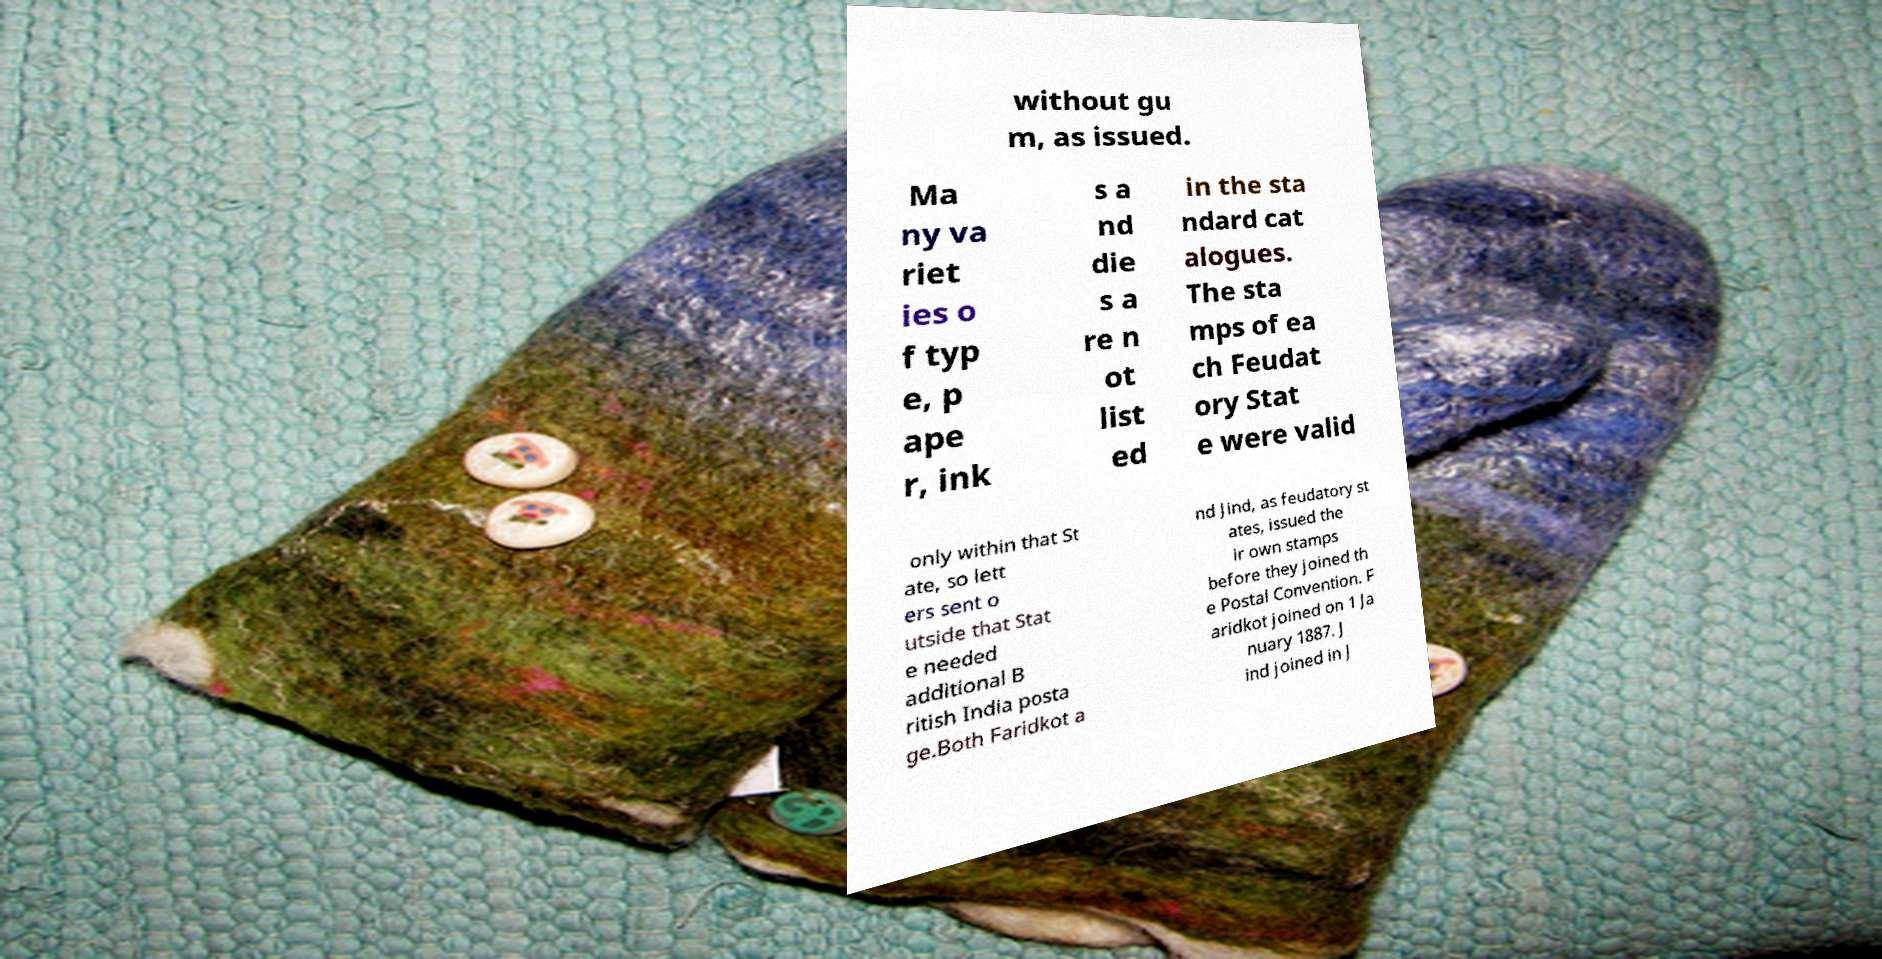What messages or text are displayed in this image? I need them in a readable, typed format. without gu m, as issued. Ma ny va riet ies o f typ e, p ape r, ink s a nd die s a re n ot list ed in the sta ndard cat alogues. The sta mps of ea ch Feudat ory Stat e were valid only within that St ate, so lett ers sent o utside that Stat e needed additional B ritish India posta ge.Both Faridkot a nd Jind, as feudatory st ates, issued the ir own stamps before they joined th e Postal Convention. F aridkot joined on 1 Ja nuary 1887. J ind joined in J 